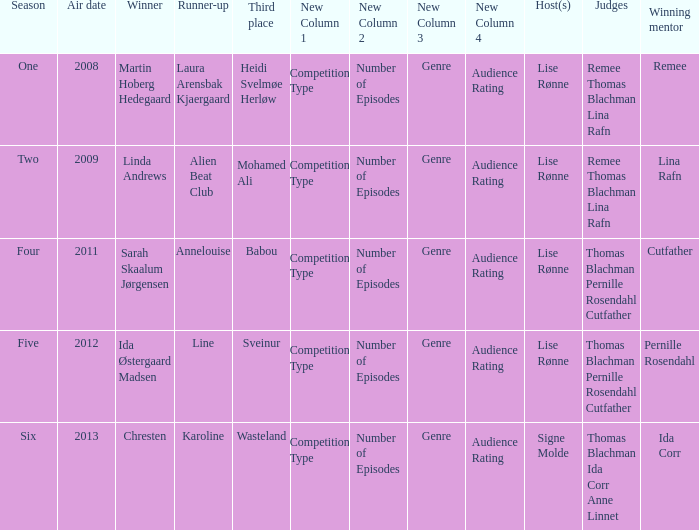Who was the winning mentor in season two? Lina Rafn. 